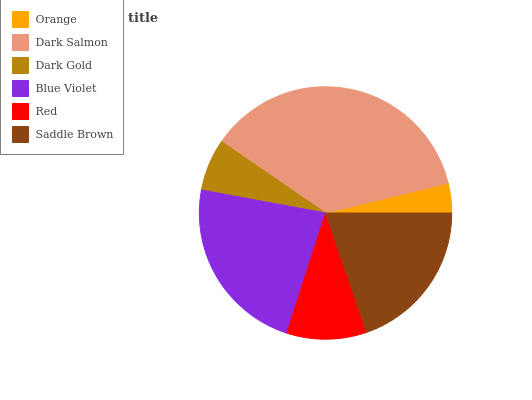Is Orange the minimum?
Answer yes or no. Yes. Is Dark Salmon the maximum?
Answer yes or no. Yes. Is Dark Gold the minimum?
Answer yes or no. No. Is Dark Gold the maximum?
Answer yes or no. No. Is Dark Salmon greater than Dark Gold?
Answer yes or no. Yes. Is Dark Gold less than Dark Salmon?
Answer yes or no. Yes. Is Dark Gold greater than Dark Salmon?
Answer yes or no. No. Is Dark Salmon less than Dark Gold?
Answer yes or no. No. Is Saddle Brown the high median?
Answer yes or no. Yes. Is Red the low median?
Answer yes or no. Yes. Is Orange the high median?
Answer yes or no. No. Is Blue Violet the low median?
Answer yes or no. No. 